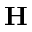Convert formula to latex. <formula><loc_0><loc_0><loc_500><loc_500>{ H }</formula> 